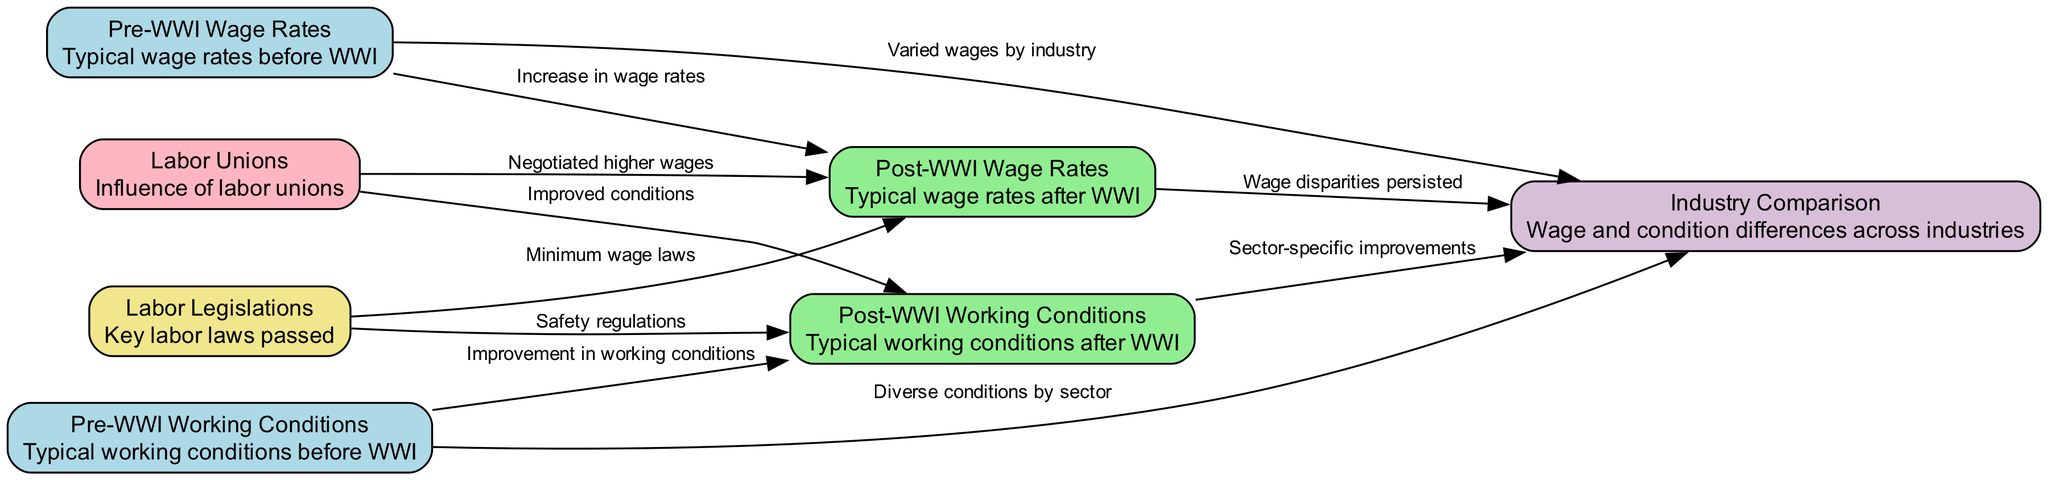What are the wage rates before WWI? The diagram indicates "Typical wage rates before WWI" in the Pre-WWI Wage Rates node.
Answer: Typical wage rates before WWI How did post-WWI working conditions compare to pre-WWI? The edge labeled "Improvement in working conditions" connects the Pre-WWI Working Conditions node to the Post-WWI Working Conditions node, indicating a positive change.
Answer: Improvement What role did labor unions play in post-WWI wage rates? The edge labeled "Negotiated higher wages" shows that labor unions directly influenced the increase in Post-WWI wage rates.
Answer: Negotiated higher wages What specific regulations improved working conditions post-WWI? The edge labeled "Safety regulations" links Labor Legislations to Post-WWI Working Conditions, indicating that such laws contributed to improved conditions.
Answer: Safety regulations What indicates the wage differences across industries? The Industry Comparison node links to both Pre-WWI Wage Rates and Post-WWI Wage Rates nodes, signifying that wage disparities existed in both periods across industries.
Answer: Wage disparities persisted How many nodes are in the diagram? By counting the nodes listed, there are a total of six distinct nodes in the diagram.
Answer: Six What were the labor conditions before WWI? The node labeled "Pre-WWI Working Conditions" contains the description "Typical working conditions before WWI," which summarizes the state at that time.
Answer: Typical working conditions before WWI Which entities were involved in improving working conditions post-WWI? Both Labor Unions and Labor Legislations are connected to Post-WWI Working Conditions, so they played a role in the improvements.
Answer: Labor Unions, Labor Legislations What is the relationship between labor legislations and wage rates post-WWI? The edge labeled "Minimum wage laws" shows that labor legislations impacted the Post-WWI wage rates, resulting in higher wages.
Answer: Minimum wage laws 